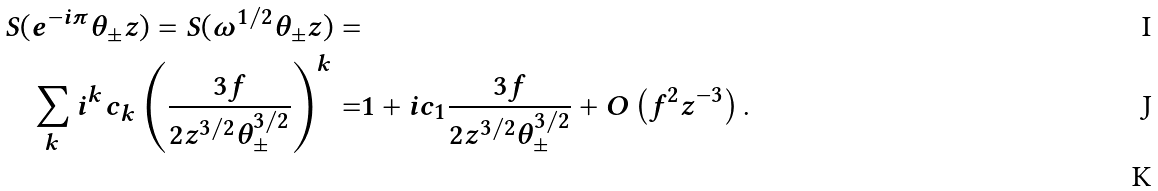Convert formula to latex. <formula><loc_0><loc_0><loc_500><loc_500>S ( e ^ { - i \pi } \theta _ { \pm } z ) = S ( \omega ^ { 1 / 2 } \theta _ { \pm } z ) = & \\ \sum _ { k } i ^ { k } c _ { k } \left ( \frac { 3 f } { 2 z ^ { 3 / 2 } \theta _ { \pm } ^ { 3 / 2 } } \right ) ^ { k } = & 1 + i c _ { 1 } \frac { 3 f } { 2 z ^ { 3 / 2 } \theta _ { \pm } ^ { 3 / 2 } } + O \left ( f ^ { 2 } z ^ { - 3 } \right ) . \\</formula> 